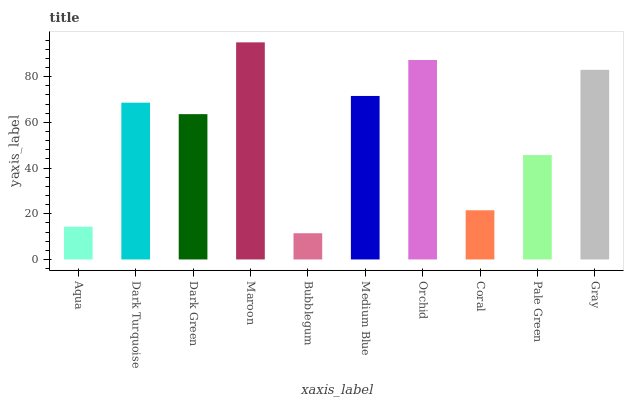Is Bubblegum the minimum?
Answer yes or no. Yes. Is Maroon the maximum?
Answer yes or no. Yes. Is Dark Turquoise the minimum?
Answer yes or no. No. Is Dark Turquoise the maximum?
Answer yes or no. No. Is Dark Turquoise greater than Aqua?
Answer yes or no. Yes. Is Aqua less than Dark Turquoise?
Answer yes or no. Yes. Is Aqua greater than Dark Turquoise?
Answer yes or no. No. Is Dark Turquoise less than Aqua?
Answer yes or no. No. Is Dark Turquoise the high median?
Answer yes or no. Yes. Is Dark Green the low median?
Answer yes or no. Yes. Is Coral the high median?
Answer yes or no. No. Is Medium Blue the low median?
Answer yes or no. No. 